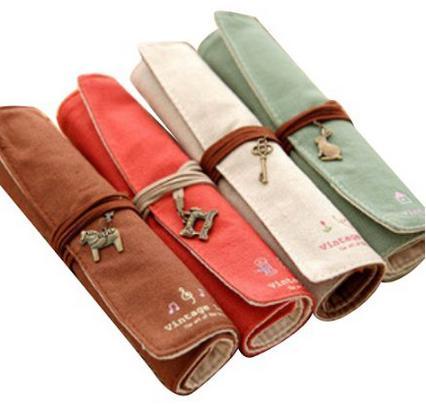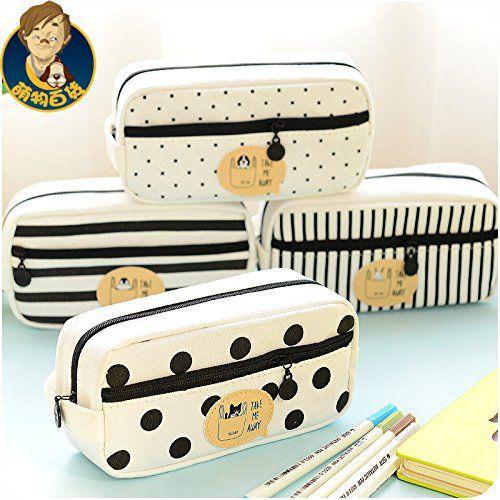The first image is the image on the left, the second image is the image on the right. Assess this claim about the two images: "The left image shows exactly four pencil cases on a white background.". Correct or not? Answer yes or no. Yes. 